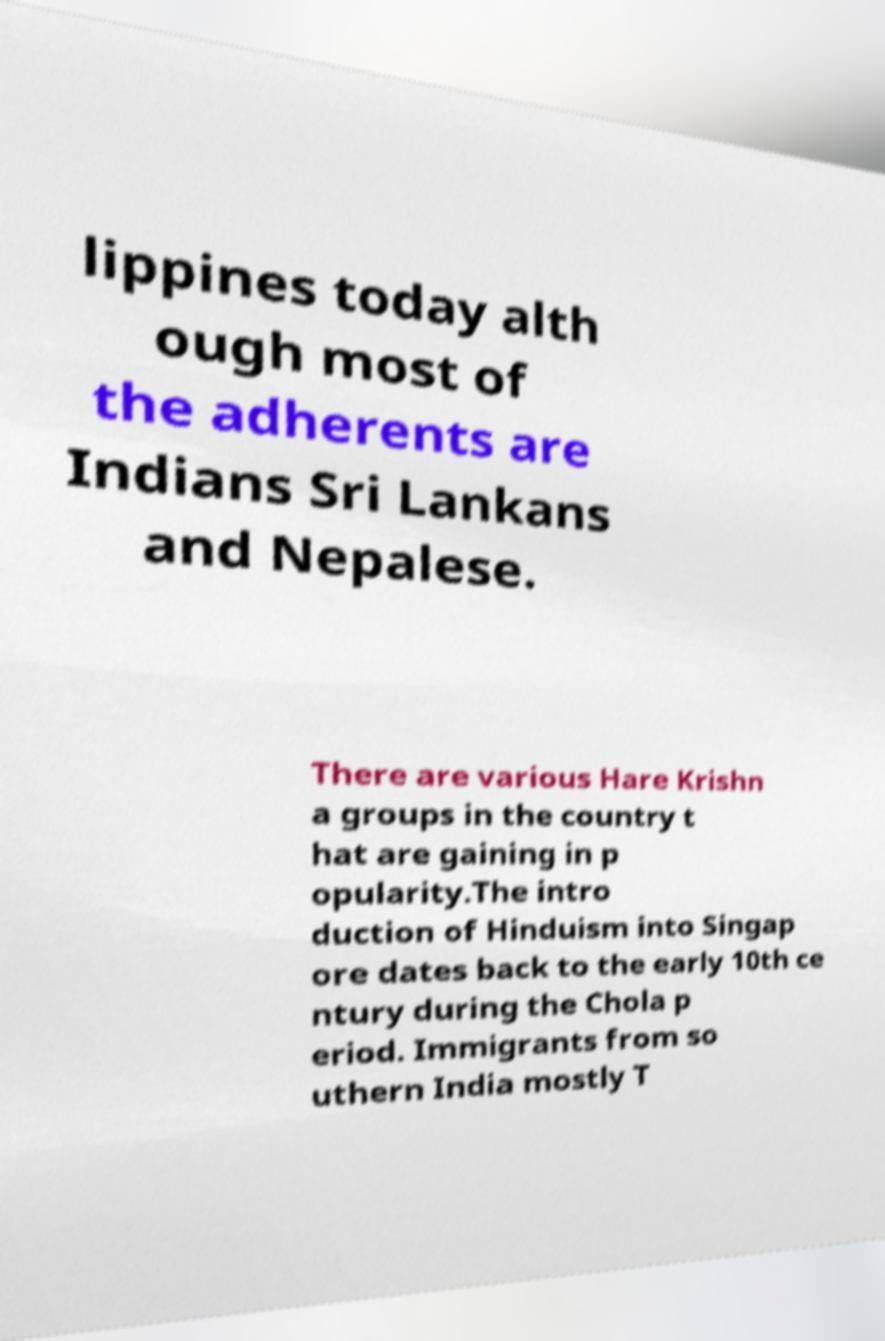I need the written content from this picture converted into text. Can you do that? lippines today alth ough most of the adherents are Indians Sri Lankans and Nepalese. There are various Hare Krishn a groups in the country t hat are gaining in p opularity.The intro duction of Hinduism into Singap ore dates back to the early 10th ce ntury during the Chola p eriod. Immigrants from so uthern India mostly T 